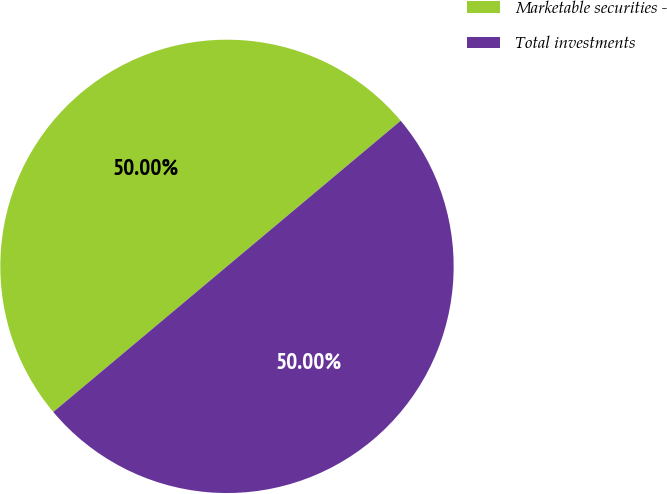Convert chart. <chart><loc_0><loc_0><loc_500><loc_500><pie_chart><fcel>Marketable securities -<fcel>Total investments<nl><fcel>50.0%<fcel>50.0%<nl></chart> 